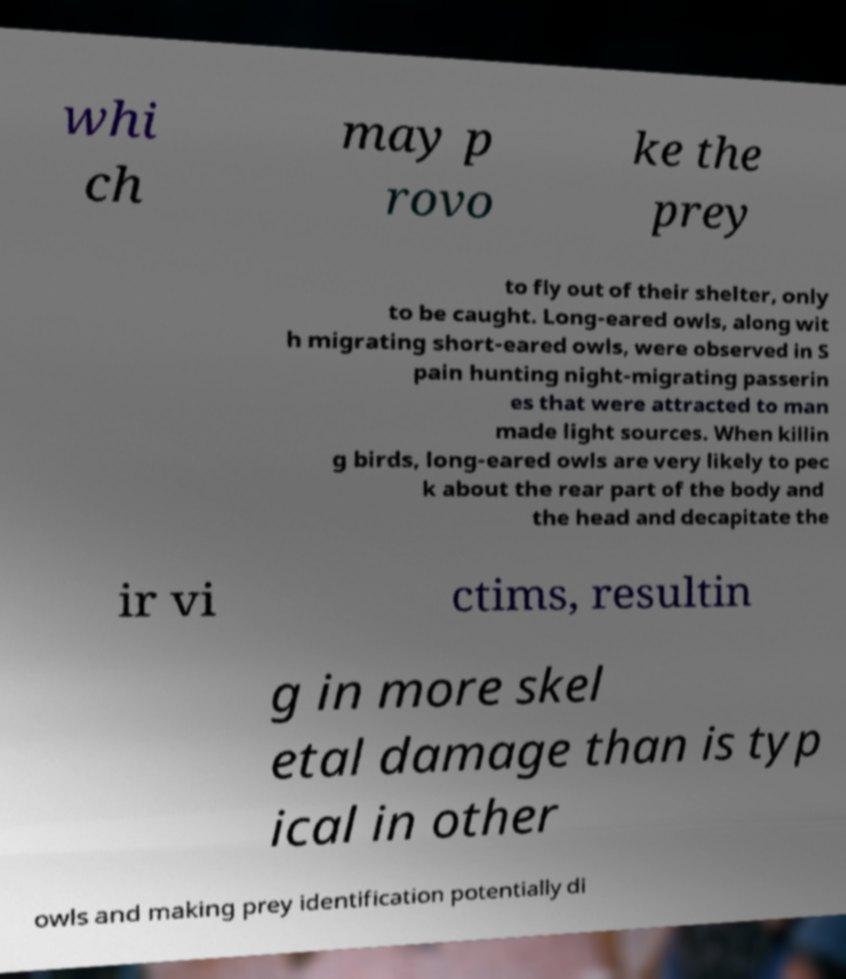For documentation purposes, I need the text within this image transcribed. Could you provide that? whi ch may p rovo ke the prey to fly out of their shelter, only to be caught. Long-eared owls, along wit h migrating short-eared owls, were observed in S pain hunting night-migrating passerin es that were attracted to man made light sources. When killin g birds, long-eared owls are very likely to pec k about the rear part of the body and the head and decapitate the ir vi ctims, resultin g in more skel etal damage than is typ ical in other owls and making prey identification potentially di 